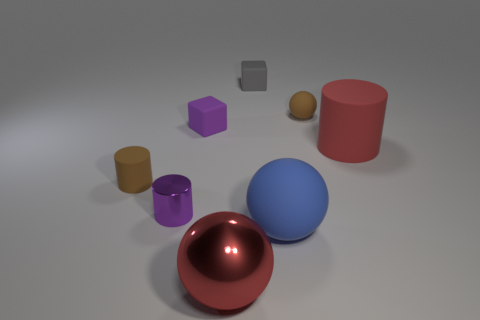How many objects are either objects on the right side of the large red metal ball or blue matte spheres?
Keep it short and to the point. 4. The tiny matte sphere is what color?
Keep it short and to the point. Brown. What is the material of the large sphere that is left of the blue matte object?
Your response must be concise. Metal. Does the big blue matte object have the same shape as the big red thing that is in front of the red rubber thing?
Ensure brevity in your answer.  Yes. Are there more large brown matte things than large cylinders?
Ensure brevity in your answer.  No. Is there anything else of the same color as the large rubber ball?
Offer a very short reply. No. There is a purple thing that is made of the same material as the red ball; what shape is it?
Your answer should be compact. Cylinder. What material is the purple thing that is in front of the purple cube that is to the left of the red metal object?
Your response must be concise. Metal. There is a brown thing behind the purple cube; is its shape the same as the red rubber object?
Keep it short and to the point. No. Are there more gray cubes left of the tiny rubber sphere than tiny red rubber cylinders?
Provide a succinct answer. Yes. 